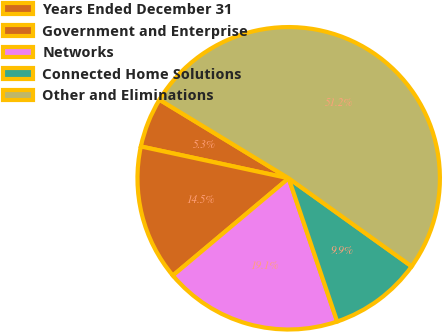Convert chart. <chart><loc_0><loc_0><loc_500><loc_500><pie_chart><fcel>Years Ended December 31<fcel>Government and Enterprise<fcel>Networks<fcel>Connected Home Solutions<fcel>Other and Eliminations<nl><fcel>5.32%<fcel>14.49%<fcel>19.08%<fcel>9.91%<fcel>51.2%<nl></chart> 